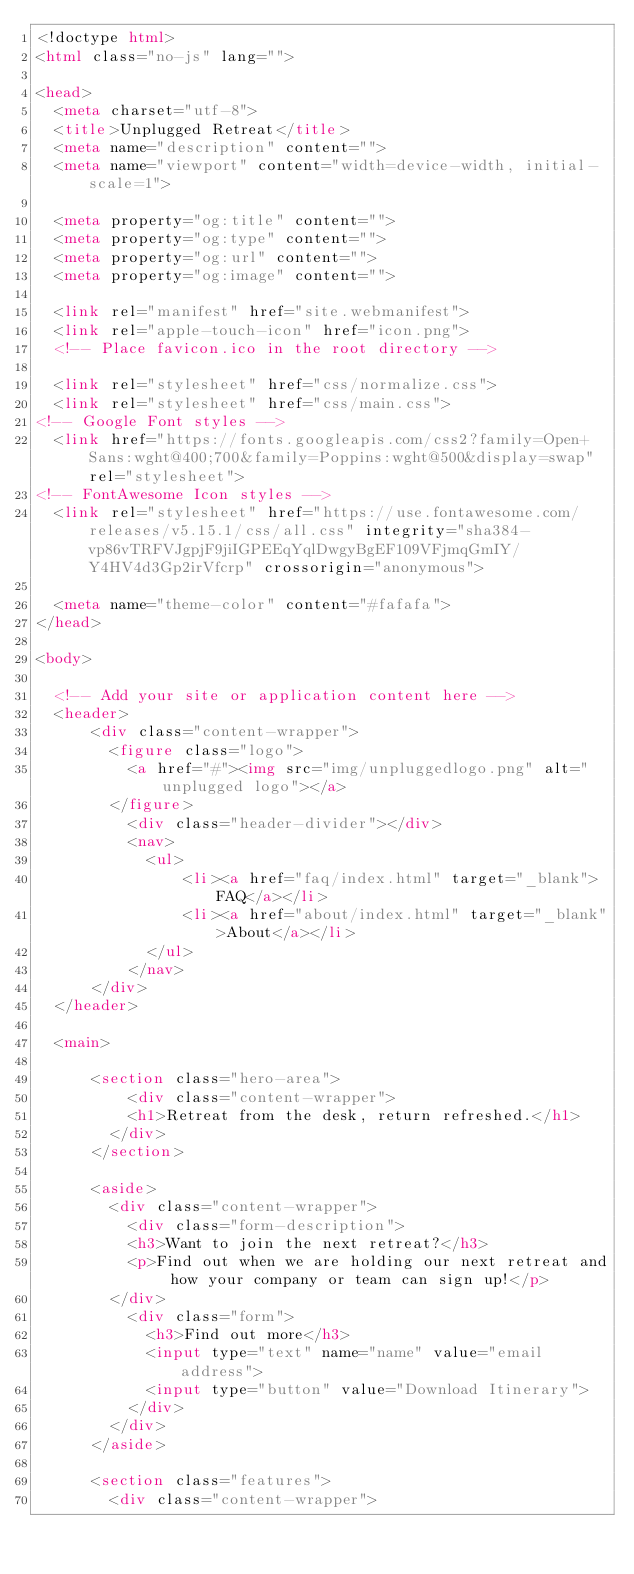<code> <loc_0><loc_0><loc_500><loc_500><_HTML_><!doctype html>
<html class="no-js" lang="">

<head>
  <meta charset="utf-8">
  <title>Unplugged Retreat</title>
  <meta name="description" content="">
  <meta name="viewport" content="width=device-width, initial-scale=1">

  <meta property="og:title" content="">
  <meta property="og:type" content="">
  <meta property="og:url" content="">
  <meta property="og:image" content="">

  <link rel="manifest" href="site.webmanifest">
  <link rel="apple-touch-icon" href="icon.png">
  <!-- Place favicon.ico in the root directory -->

  <link rel="stylesheet" href="css/normalize.css">
  <link rel="stylesheet" href="css/main.css">
<!-- Google Font styles -->
  <link href="https://fonts.googleapis.com/css2?family=Open+Sans:wght@400;700&family=Poppins:wght@500&display=swap" rel="stylesheet">  
<!-- FontAwesome Icon styles -->
  <link rel="stylesheet" href="https://use.fontawesome.com/releases/v5.15.1/css/all.css" integrity="sha384-vp86vTRFVJgpjF9jiIGPEEqYqlDwgyBgEF109VFjmqGmIY/Y4HV4d3Gp2irVfcrp" crossorigin="anonymous">

  <meta name="theme-color" content="#fafafa">
</head>

<body>

  <!-- Add your site or application content here -->
  <header>
      <div class="content-wrapper">
        <figure class="logo">
          <a href="#"><img src="img/unpluggedlogo.png" alt="unplugged logo"></a>
        </figure>
          <div class="header-divider"></div>
          <nav>
            <ul>
                <li><a href="faq/index.html" target="_blank">FAQ</a></li>
                <li><a href="about/index.html" target="_blank">About</a></li>
            </ul>
          </nav>
      </div>
  </header>

  <main>

      <section class="hero-area">
          <div class="content-wrapper">
          <h1>Retreat from the desk, return refreshed.</h1>
        </div>
      </section>

      <aside>
        <div class="content-wrapper">
          <div class="form-description">
          <h3>Want to join the next retreat?</h3>
          <p>Find out when we are holding our next retreat and how your company or team can sign up!</p>
        </div>
          <div class="form">
            <h3>Find out more</h3>
            <input type="text" name="name" value="email address">
            <input type="button" value="Download Itinerary">
          </div>
        </div>
      </aside>

      <section class="features">
        <div class="content-wrapper"></code> 